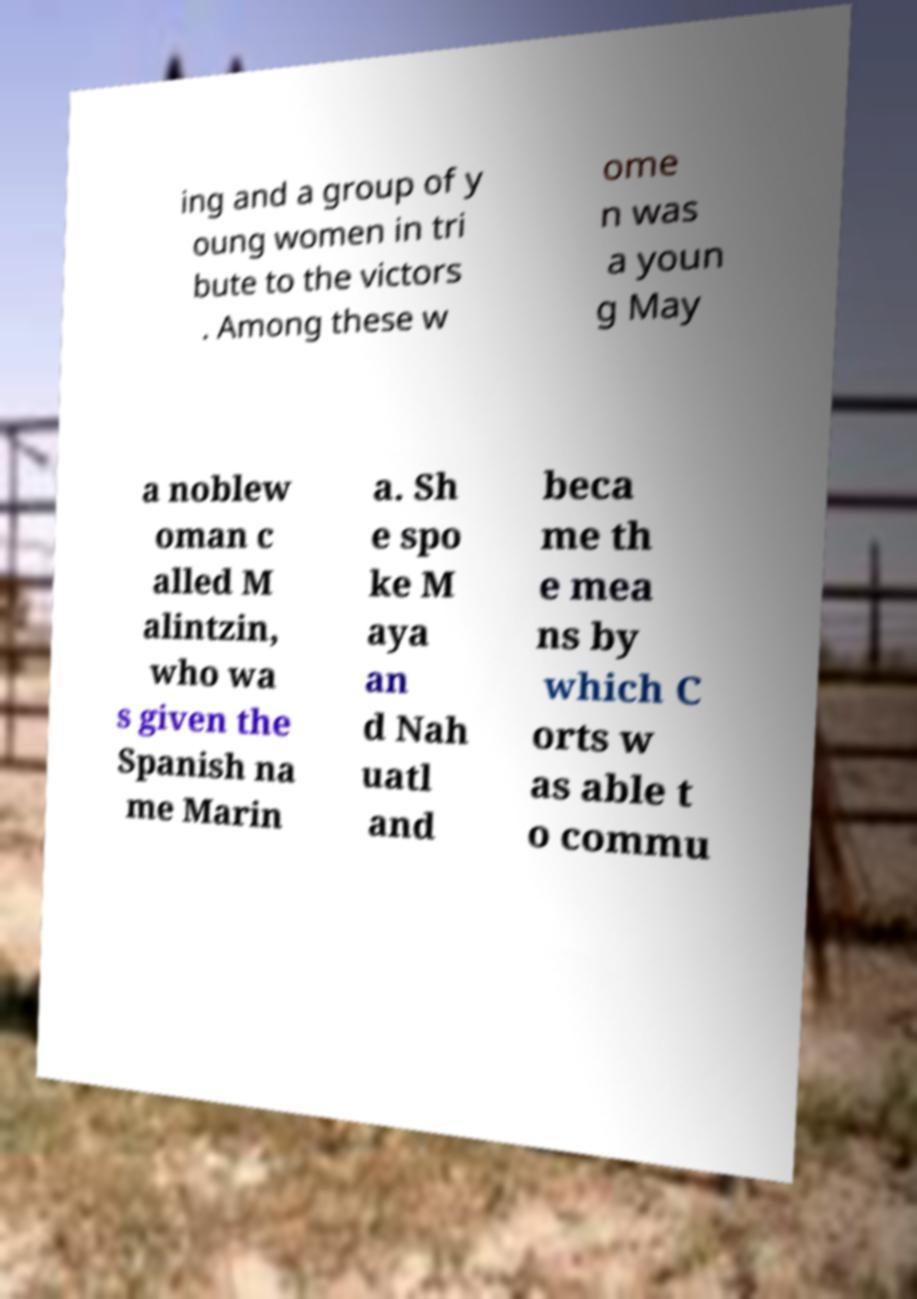What messages or text are displayed in this image? I need them in a readable, typed format. ing and a group of y oung women in tri bute to the victors . Among these w ome n was a youn g May a noblew oman c alled M alintzin, who wa s given the Spanish na me Marin a. Sh e spo ke M aya an d Nah uatl and beca me th e mea ns by which C orts w as able t o commu 